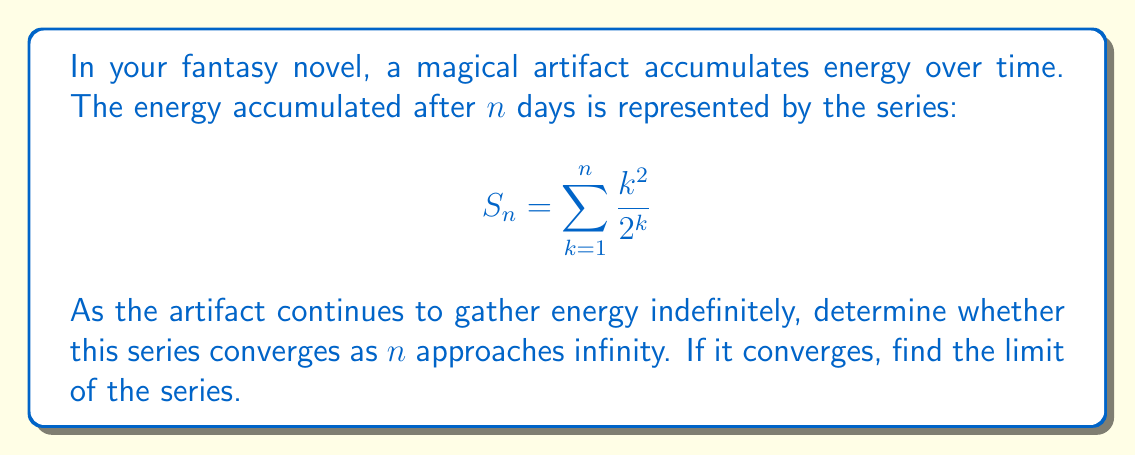Help me with this question. To analyze the convergence of this series, we'll use the ratio test:

1) First, let's define the general term of the series:
   $$ a_k = \frac{k^2}{2^k} $$

2) Now, we'll calculate the limit of the ratio of consecutive terms:
   $$ \lim_{k \to \infty} \left|\frac{a_{k+1}}{a_k}\right| = \lim_{k \to \infty} \left|\frac{(k+1)^2}{2^{k+1}} \cdot \frac{2^k}{k^2}\right| $$

3) Simplify:
   $$ \lim_{k \to \infty} \left|\frac{(k+1)^2}{2k^2}\right| = \lim_{k \to \infty} \frac{k^2 + 2k + 1}{2k^2} $$

4) Divide numerator and denominator by $k^2$:
   $$ \lim_{k \to \infty} \frac{1 + \frac{2}{k} + \frac{1}{k^2}}{2} = \frac{1}{2} $$

5) Since the limit is less than 1, the series converges.

To find the sum of the series, we can use the following approach:

6) Let $S = \sum_{k=1}^{\infty} \frac{k^2}{2^k}$

7) Multiply both sides by 2:
   $$ 2S = \sum_{k=1}^{\infty} \frac{k^2}{2^{k-1}} $$

8) Subtract $S$ from $2S$:
   $$ S = 2S - S = \sum_{k=1}^{\infty} \frac{k^2}{2^{k-1}} - \sum_{k=1}^{\infty} \frac{k^2}{2^k} $$

9) Simplify:
   $$ S = \sum_{k=1}^{\infty} \frac{k^2}{2^k} = \sum_{k=1}^{\infty} \frac{k^2}{2^{k-1}} - 2\sum_{k=1}^{\infty} \frac{k^2}{2^k} $$

10) Rearrange:
    $$ 3S = \sum_{k=1}^{\infty} \frac{k^2}{2^{k-1}} $$

11) Now, we can use the fact that $\sum_{k=1}^{\infty} kx^k = \frac{x}{(1-x)^2}$ for $|x| < 1$

12) Differentiate both sides with respect to $x$:
    $$ \sum_{k=1}^{\infty} k^2x^{k-1} = \frac{1+x}{(1-x)^3} $$

13) Set $x = \frac{1}{2}$:
    $$ \sum_{k=1}^{\infty} \frac{k^2}{2^{k-1}} = \frac{1+\frac{1}{2}}{(1-\frac{1}{2})^3} = \frac{3}{(\frac{1}{2})^3} = 24 $$

14) Therefore:
    $$ 3S = 24 $$
    $$ S = 8 $$
Answer: The series converges, and its sum is 8. 